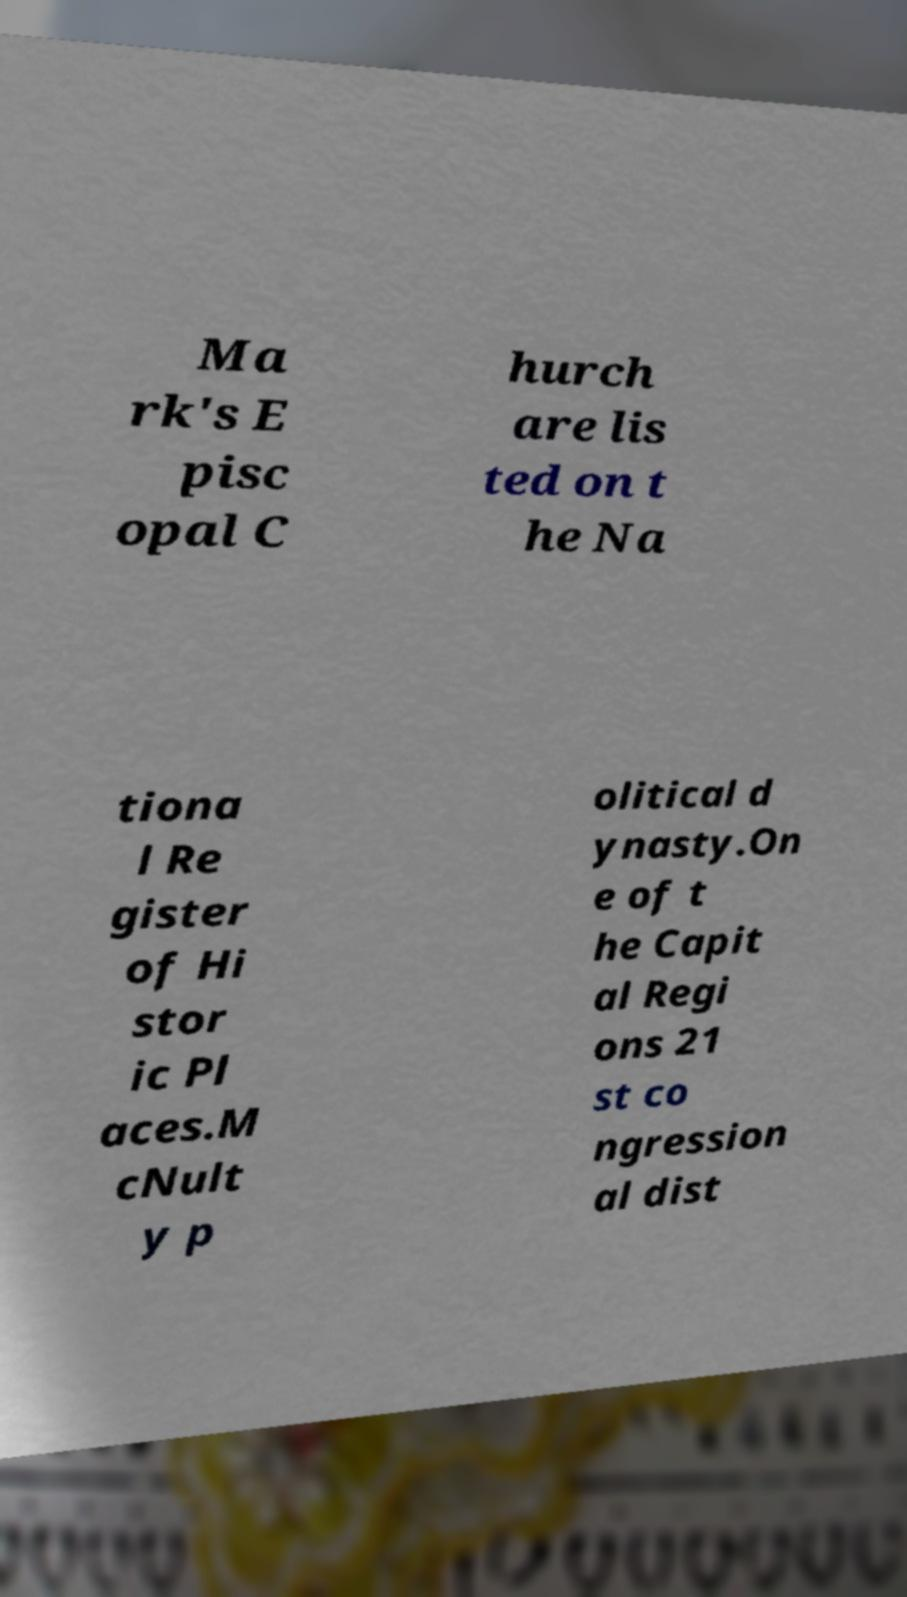Please read and relay the text visible in this image. What does it say? Ma rk's E pisc opal C hurch are lis ted on t he Na tiona l Re gister of Hi stor ic Pl aces.M cNult y p olitical d ynasty.On e of t he Capit al Regi ons 21 st co ngression al dist 